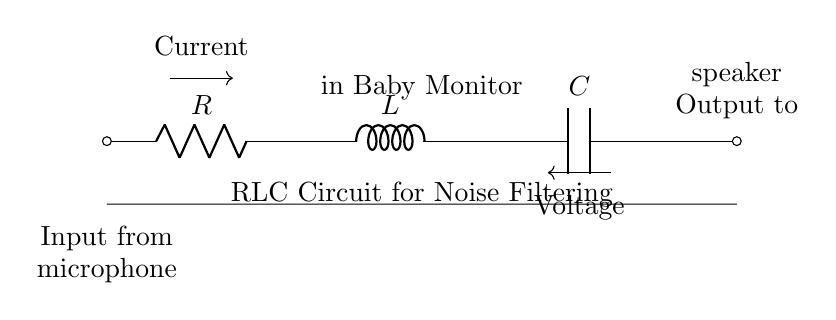What components are included in this circuit? The circuit consists of a resistor, inductor, and capacitor, as indicated by the labels on the diagram. The components are connected in series, which is common in RLC circuits.
Answer: Resistor, Inductor, Capacitor What is the primary function of the RLC circuit in the baby monitor? The primary function of the RLC circuit is to filter noise and improve audio clarity by allowing certain frequencies to pass while attenuating others, which is essential for clear audio transmission in a baby monitor.
Answer: Noise filtering and clear audio transmission Where does the input signal come from? The diagram shows that the input signal comes from a microphone, as indicated by the label on the left side of the diagram. It connects to the resistor where the audio signal first enters the circuit.
Answer: Microphone What is the role of the capacitor in this circuit? The capacitor in this RLC circuit stores energy and can block certain frequencies of the signal passing through, which helps in smoothing out the audio output for better clarity. It works in conjunction with the inductor and resistor to shape the response of the circuit to frequencies.
Answer: Energy storage and frequency response shaping What happens to high-frequency noise in the RLC circuit? High-frequency noise is typically attenuated or reduced by the RLC circuit, as the combination of the inductor and capacitor can create a frequency-dependent impedance. This means that high frequencies face more resistance, which helps in filtering them out.
Answer: Attenuated or reduced How is current direction indicated in the circuit? The current direction is indicated by the arrow labeled "Current," which shows the flow of current from the microphone input through the resistor, inductor, and capacitor towards the speaker output in a specified direction.
Answer: By an arrow labeled "Current." 